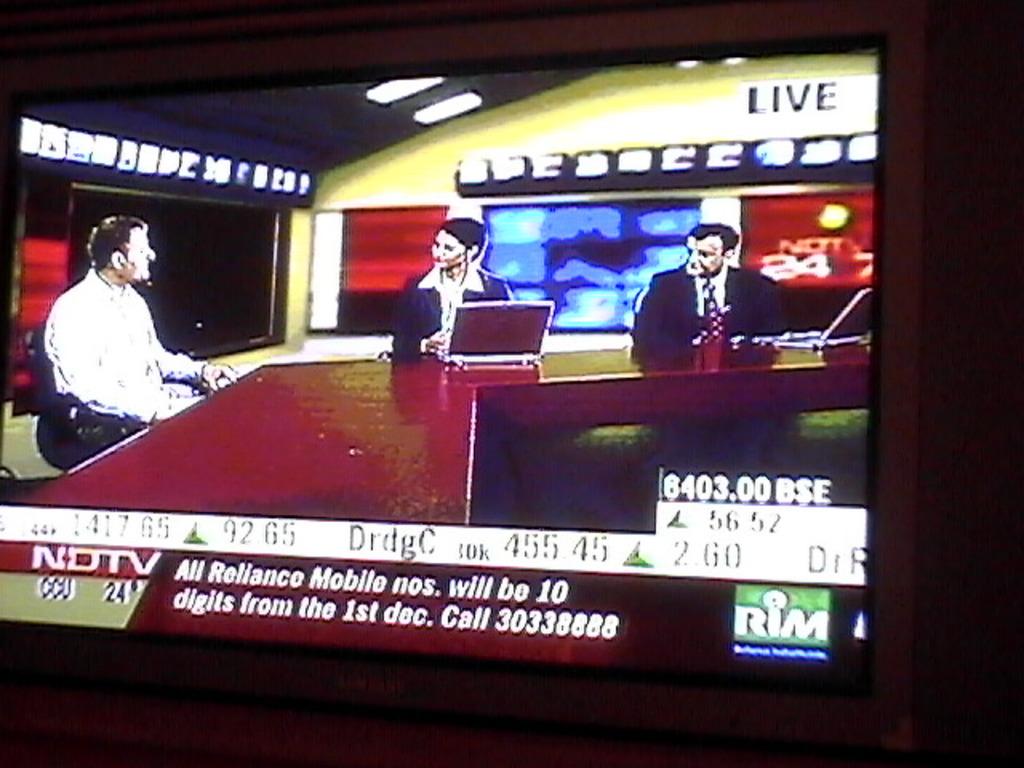Is this live tv?
Your response must be concise. Yes. What television station is being broadcast?
Offer a terse response. Ndtv. 